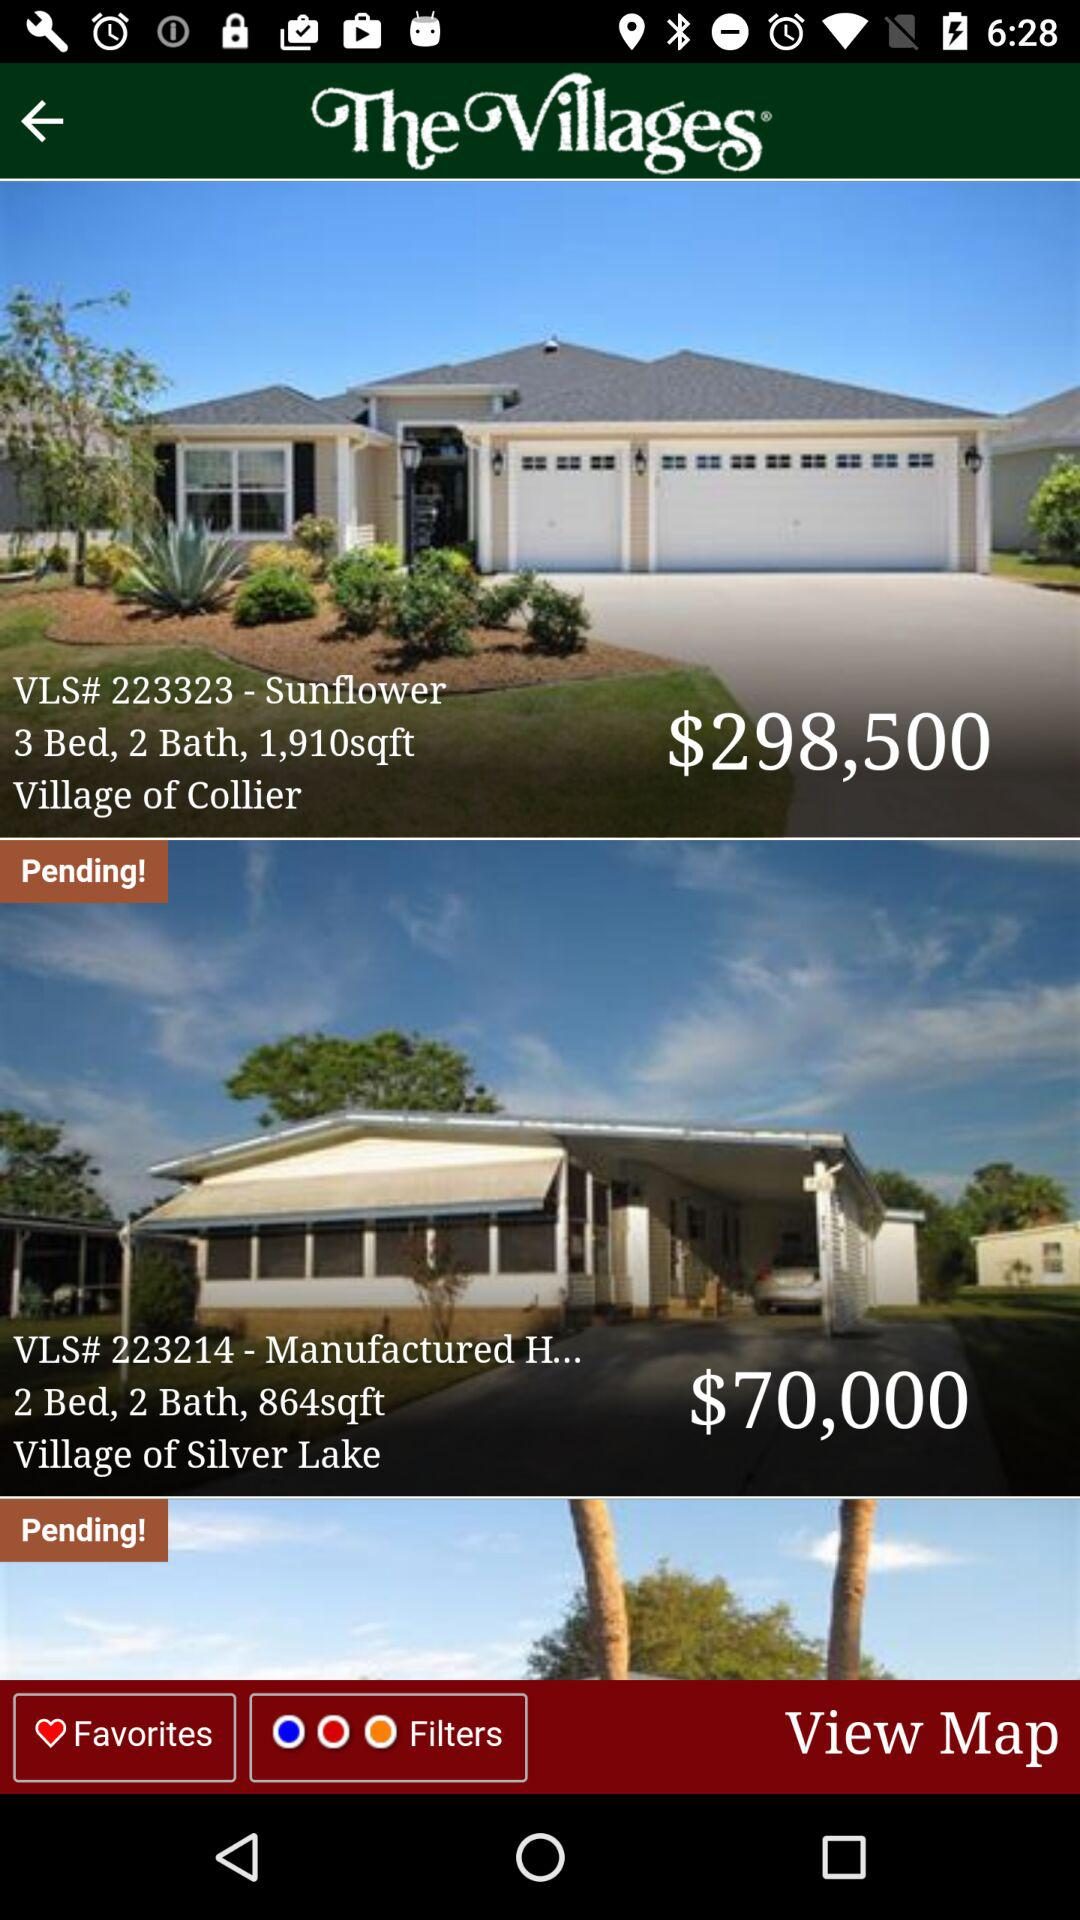What is the count of beds and baths for the village of Collier? The count of beds and baths for the village of Collier is 3 and 2. 